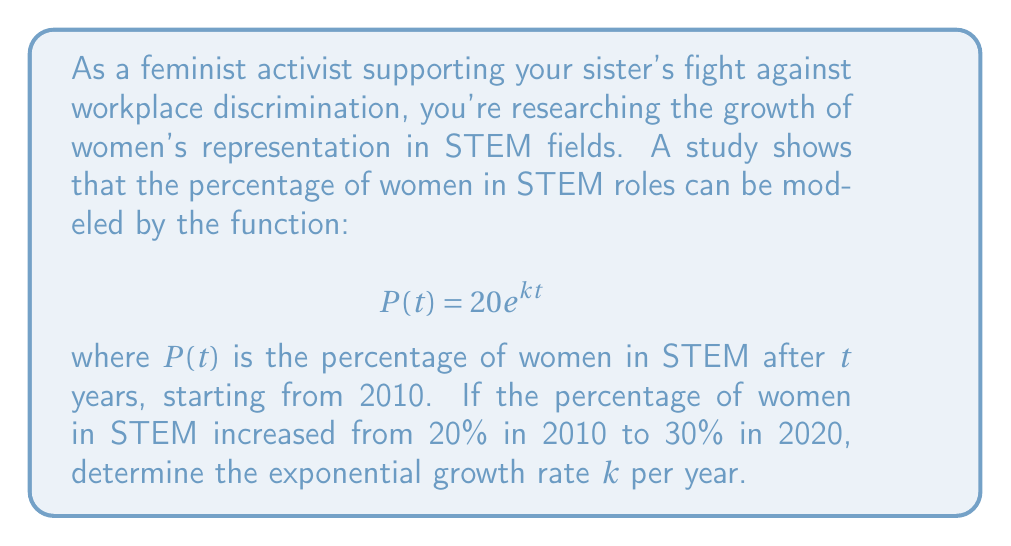Give your solution to this math problem. 1) We're given the general form of the exponential growth function:
   $$P(t) = 20e^{kt}$$

2) We know two points on this curve:
   At $t=0$ (2010): $P(0) = 20$
   At $t=10$ (2020): $P(10) = 30$

3) Let's use the point at $t=10$ to set up an equation:
   $$30 = 20e^{k(10)}$$

4) Divide both sides by 20:
   $$\frac{30}{20} = e^{10k}$$

5) Simplify:
   $$1.5 = e^{10k}$$

6) Take the natural log of both sides:
   $$\ln(1.5) = \ln(e^{10k})$$

7) Simplify the right side using the properties of logarithms:
   $$\ln(1.5) = 10k$$

8) Solve for $k$:
   $$k = \frac{\ln(1.5)}{10}$$

9) Calculate the value:
   $$k \approx 0.0405$$

This means the growth rate is approximately 4.05% per year.
Answer: $k \approx 0.0405$ or 4.05% per year 